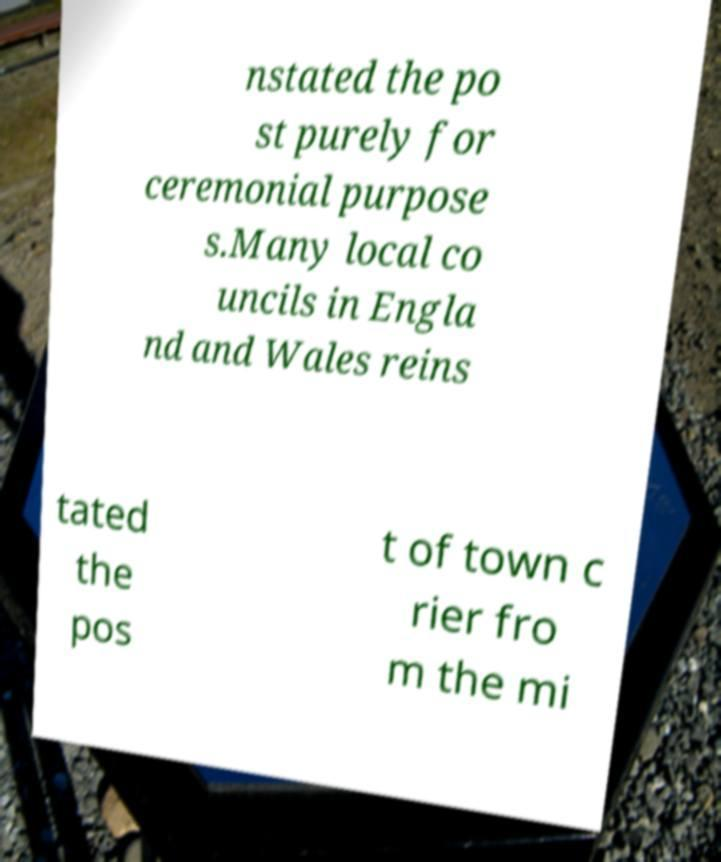Please read and relay the text visible in this image. What does it say? nstated the po st purely for ceremonial purpose s.Many local co uncils in Engla nd and Wales reins tated the pos t of town c rier fro m the mi 